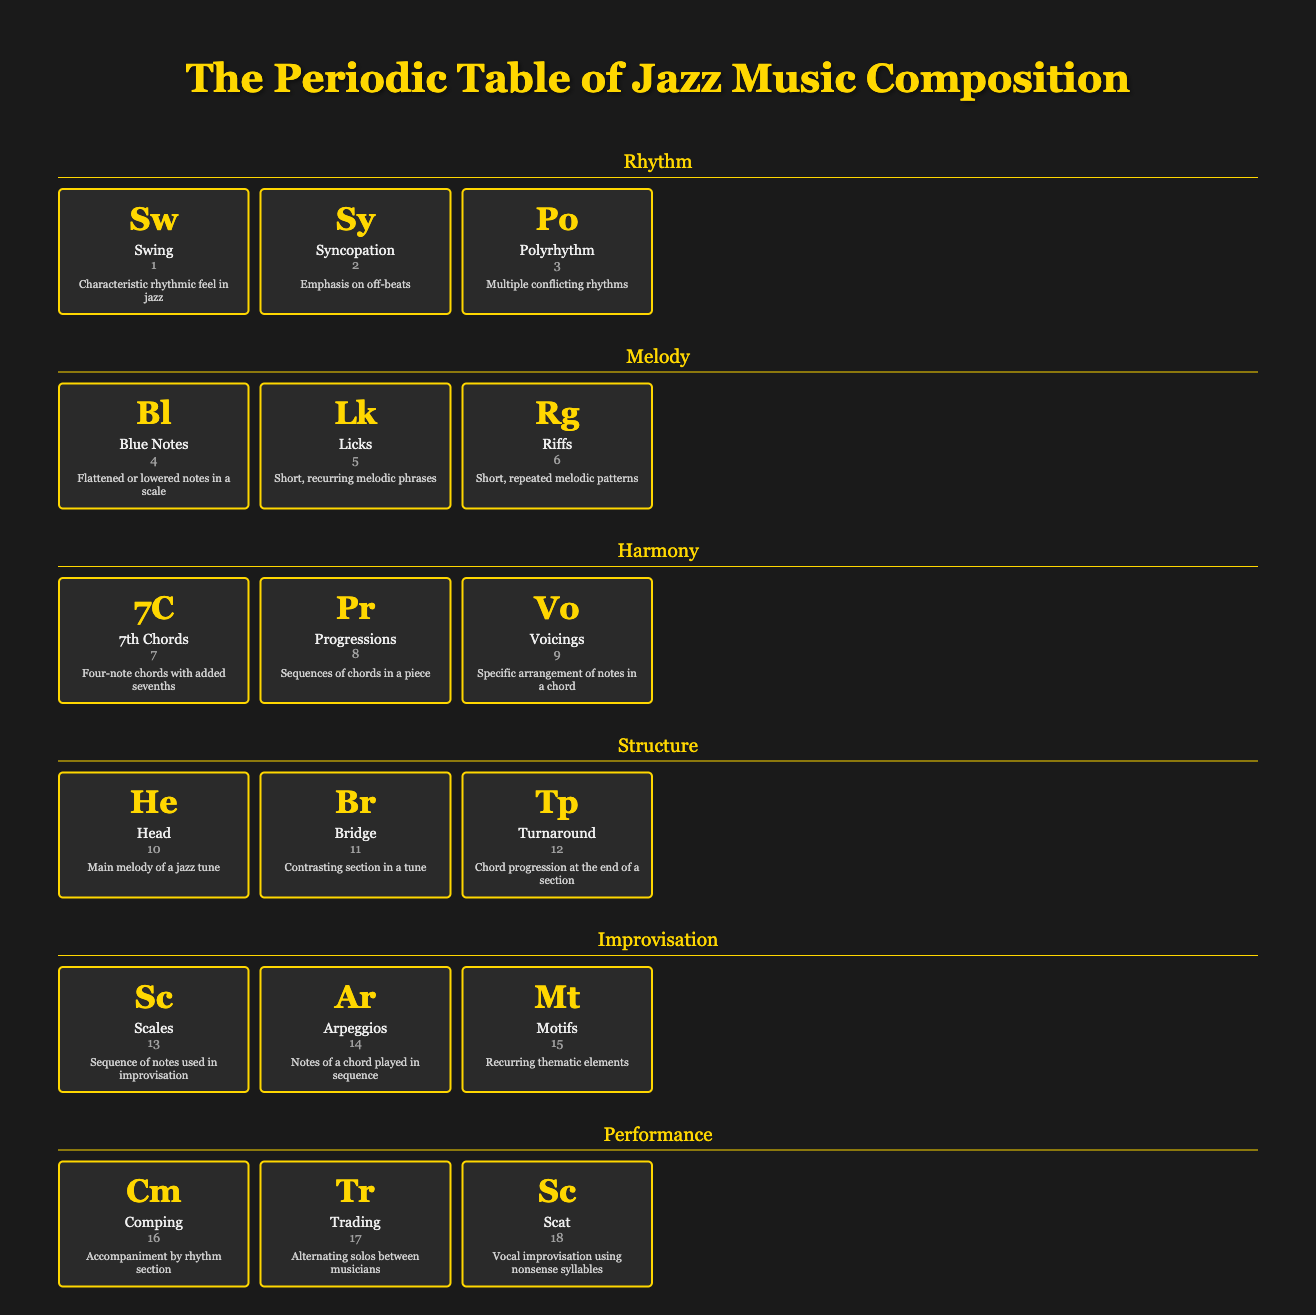What is the symbol for Blue Notes? The table shows that the symbol for Blue Notes is "Bl."
Answer: Bl Which element emphasizes off-beats? According to the table, Syncopation is the element that emphasizes off-beats.
Answer: Syncopation How many elements are there in the Structure group? The Structure group contains three elements: Head, Bridge, and Turnaround, which gives us a total of three.
Answer: 3 Are there more elements in the Rhythm group than in the Harmony group? The Rhythm group has three elements, while the Harmony group also has three. So, there are not more elements in the Rhythm group.
Answer: No What is the difference in the number of elements between the Performance and Improvisation groups? The Performance group has three elements (Comping, Trading, Scat), and the Improvisation group also has three elements (Scales, Arpeggios, Motifs). Therefore, the difference is zero.
Answer: 0 Which element has the description "Main melody of a jazz tune"? Referring to the table, the element that has this description is "Head."
Answer: Head What is the third element in the Harmony group? The Harmony group contains 7th Chords, Progressions, and Voicings. Therefore, the third element is Voicings.
Answer: Voicings Identify an element that uses nonsense syllables in its improvisation. According to the table, the element that uses nonsense syllables for vocal improvisation is "Scat."
Answer: Scat Which rhythmic element has a description related to “multiple conflicting rhythms”? The table indicates that the element which has this description is "Polyrhythm."
Answer: Polyrhythm What is the total number of all elements across all groups? Counting the elements in each group: Rhythm (3) + Melody (3) + Harmony (3) + Structure (3) + Improvisation (3) + Performance (3) equals a total of 18 elements.
Answer: 18 